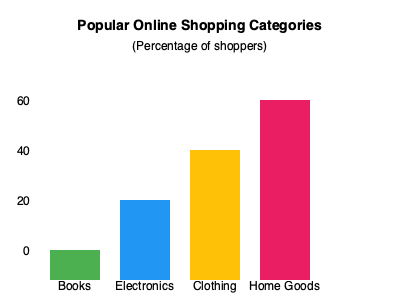Based on the bar graph, which category is the most popular among online shoppers? To determine the most popular category among online shoppers, we need to compare the heights of the bars in the graph. Each bar represents a different category, and the height of the bar indicates the percentage of shoppers who prefer that category. Let's examine each category:

1. Books (green bar): This is the shortest bar, indicating the lowest percentage.
2. Electronics (blue bar): This bar is taller than Books but shorter than the others.
3. Clothing (yellow bar): This bar is the second tallest.
4. Home Goods (pink bar): This is the tallest bar in the graph.

Since the Home Goods bar is the tallest, it represents the highest percentage of shoppers. Therefore, Home Goods is the most popular category among online shoppers according to this graph.
Answer: Home Goods 